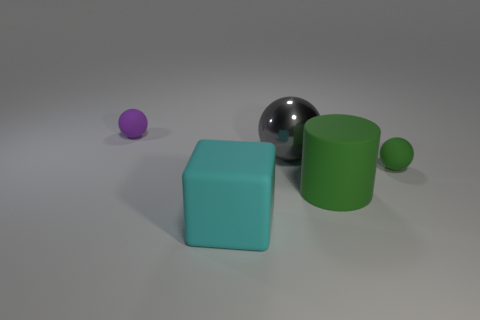Subtract all tiny purple matte balls. How many balls are left? 2 Subtract all purple spheres. How many spheres are left? 2 Subtract 2 spheres. How many spheres are left? 1 Add 3 large gray metal objects. How many objects exist? 8 Subtract all cylinders. How many objects are left? 4 Subtract all purple balls. Subtract all red cylinders. How many balls are left? 2 Subtract all brown cylinders. How many green blocks are left? 0 Subtract all large cyan metallic balls. Subtract all tiny green matte balls. How many objects are left? 4 Add 1 green matte things. How many green matte things are left? 3 Add 3 large matte cylinders. How many large matte cylinders exist? 4 